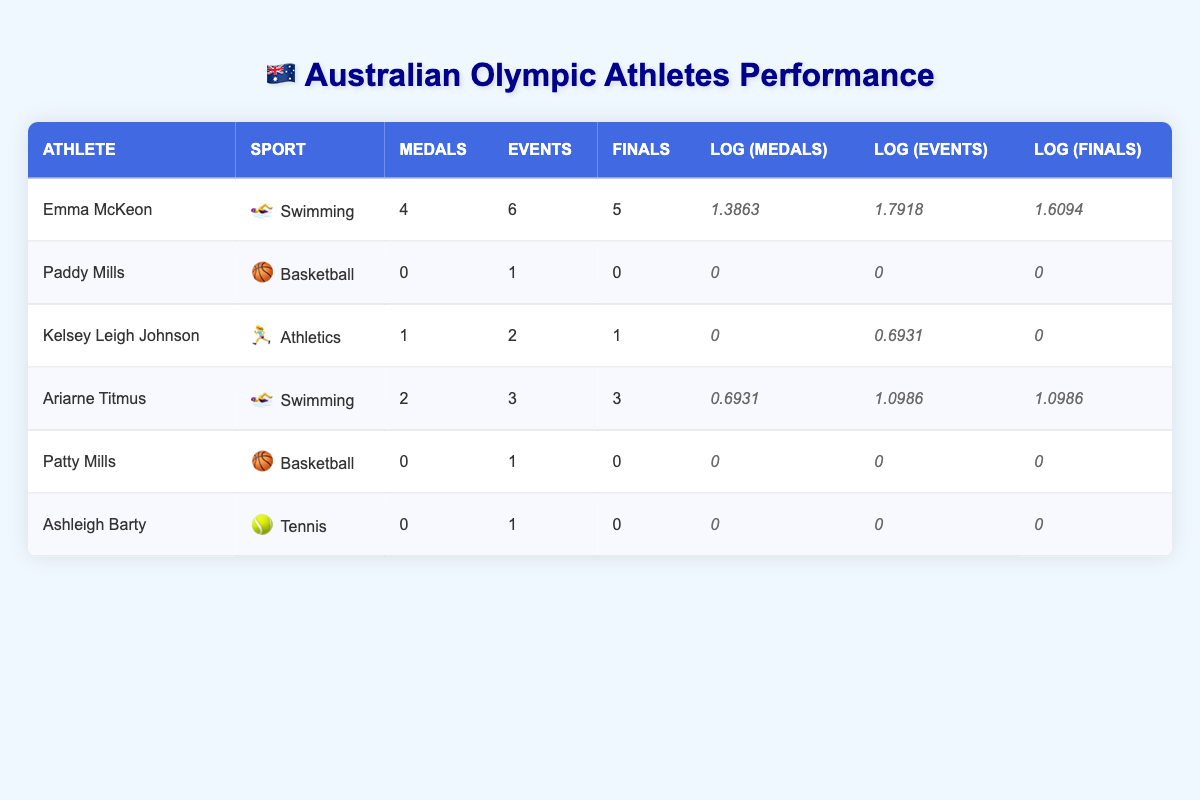What is the total number of medals won by Australian athletes in the Olympic Games? By summing the "Medals" column for all athletes, we have 4 (Emma McKeon) + 0 (Paddy Mills) + 1 (Kelsey Leigh Johnson) + 2 (Ariarne Titmus) + 0 (Patty Mills) + 0 (Ashleigh Barty) = 7 medals in total.
Answer: 7 Which athlete won the most events? By looking at the "Events" column, we can see Emma McKeon participated in 6 events, more than any other athlete.
Answer: Emma McKeon Did any athlete win a medal and also reach the finals in all events they participated in? Checking the data, only Emma McKeon and Ariarne Titmus reached the finals in all of their events; however, only Emma McKeon won medals in her events, confirming she fits the criteria.
Answer: Yes What is the average number of medals per athlete for those who won medals? Only three athletes won medals: Emma McKeon, Kelsey Leigh Johnson, and Ariarne Titmus. The total number of medals won is 7. Since there are 3 athletes, the average is 7 / 3 = 2.33.
Answer: 2.33 Which sport had athletes who did not win any medals? Both Basketball (Paddy Mills and Patty Mills) and Tennis (Ashleigh Barty) had athletes that did not win any medals.
Answer: Basketball and Tennis 